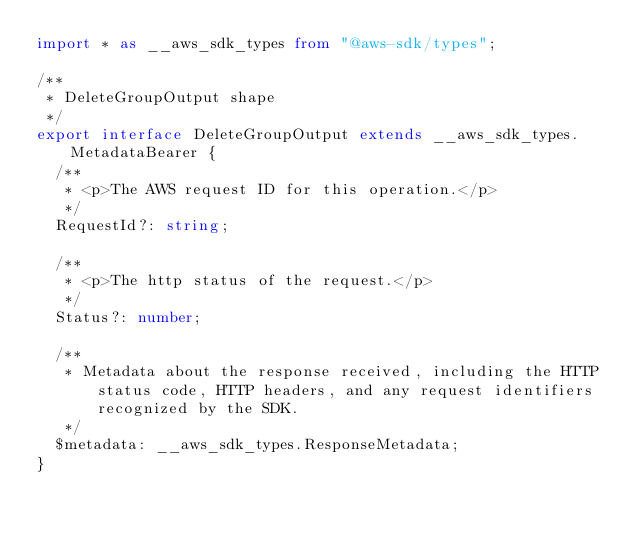<code> <loc_0><loc_0><loc_500><loc_500><_TypeScript_>import * as __aws_sdk_types from "@aws-sdk/types";

/**
 * DeleteGroupOutput shape
 */
export interface DeleteGroupOutput extends __aws_sdk_types.MetadataBearer {
  /**
   * <p>The AWS request ID for this operation.</p>
   */
  RequestId?: string;

  /**
   * <p>The http status of the request.</p>
   */
  Status?: number;

  /**
   * Metadata about the response received, including the HTTP status code, HTTP headers, and any request identifiers recognized by the SDK.
   */
  $metadata: __aws_sdk_types.ResponseMetadata;
}
</code> 